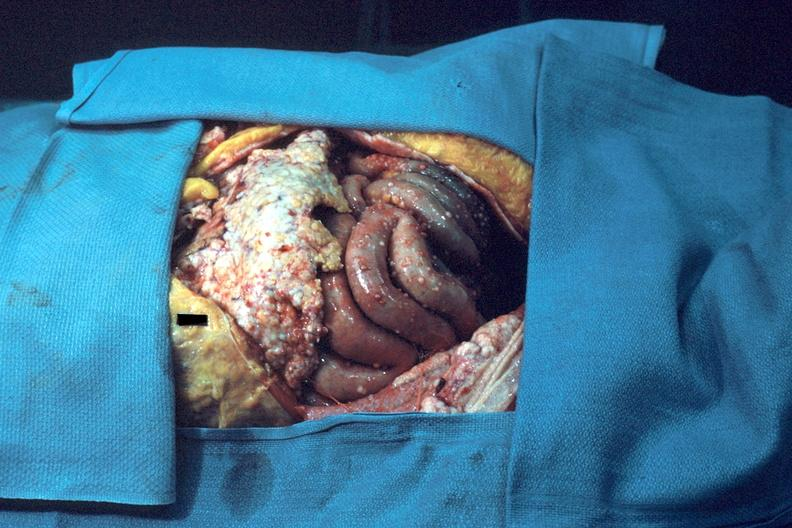what does this image show?
Answer the question using a single word or phrase. Opened abdominal cavity show typical carcinomatosis 